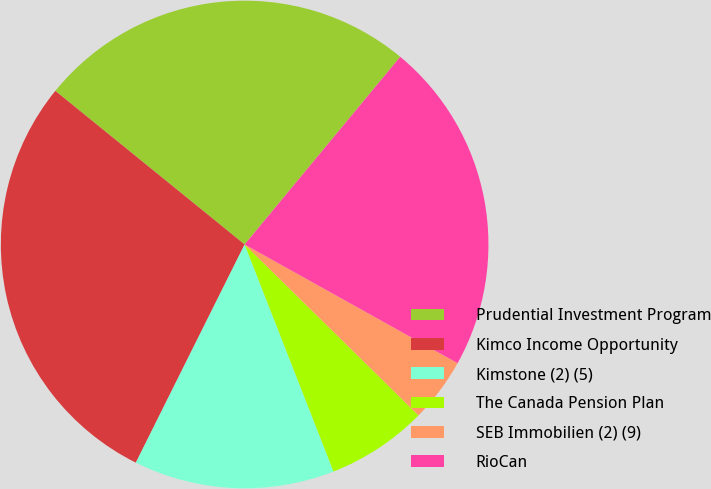Convert chart to OTSL. <chart><loc_0><loc_0><loc_500><loc_500><pie_chart><fcel>Prudential Investment Program<fcel>Kimco Income Opportunity<fcel>Kimstone (2) (5)<fcel>The Canada Pension Plan<fcel>SEB Immobilien (2) (9)<fcel>RioCan<nl><fcel>25.17%<fcel>28.49%<fcel>13.3%<fcel>6.7%<fcel>4.27%<fcel>22.08%<nl></chart> 